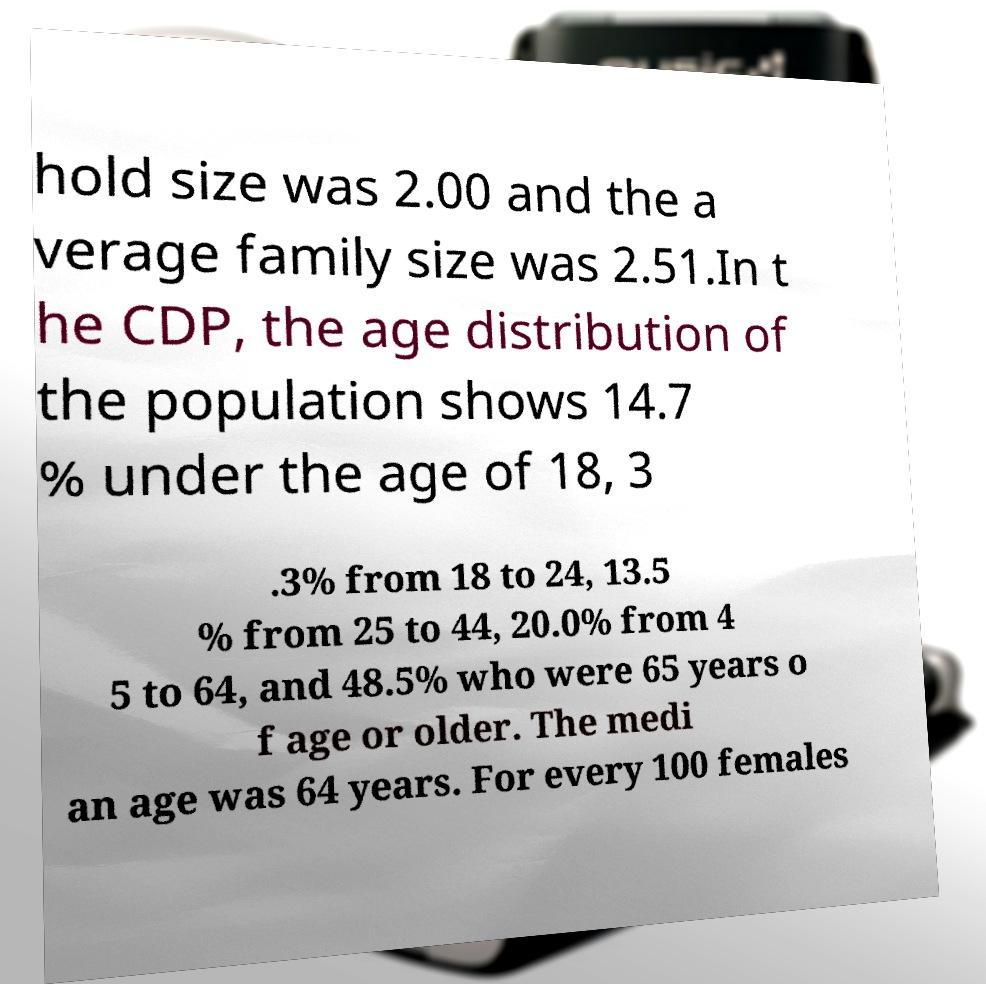There's text embedded in this image that I need extracted. Can you transcribe it verbatim? hold size was 2.00 and the a verage family size was 2.51.In t he CDP, the age distribution of the population shows 14.7 % under the age of 18, 3 .3% from 18 to 24, 13.5 % from 25 to 44, 20.0% from 4 5 to 64, and 48.5% who were 65 years o f age or older. The medi an age was 64 years. For every 100 females 